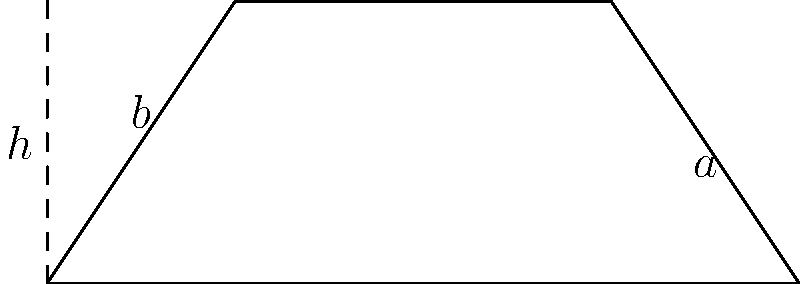As you revisit geometry in your studies, consider a trapezoid with parallel sides of lengths $a = 6$ cm and $b = 2$ cm, and a height of $h = 3$ cm. Calculate the area of this trapezoid. To find the area of a trapezoid, we can use the formula:

$$A = \frac{1}{2}(a + b)h$$

Where:
$A$ = Area of the trapezoid
$a$ = Length of one parallel side
$b$ = Length of the other parallel side
$h$ = Height of the trapezoid

Given:
$a = 6$ cm
$b = 2$ cm
$h = 3$ cm

Let's substitute these values into the formula:

$$A = \frac{1}{2}(6 + 2) \times 3$$

Simplify inside the parentheses:
$$A = \frac{1}{2}(8) \times 3$$

Multiply:
$$A = 4 \times 3 = 12$$

Therefore, the area of the trapezoid is 12 square centimeters.
Answer: $12 \text{ cm}^2$ 